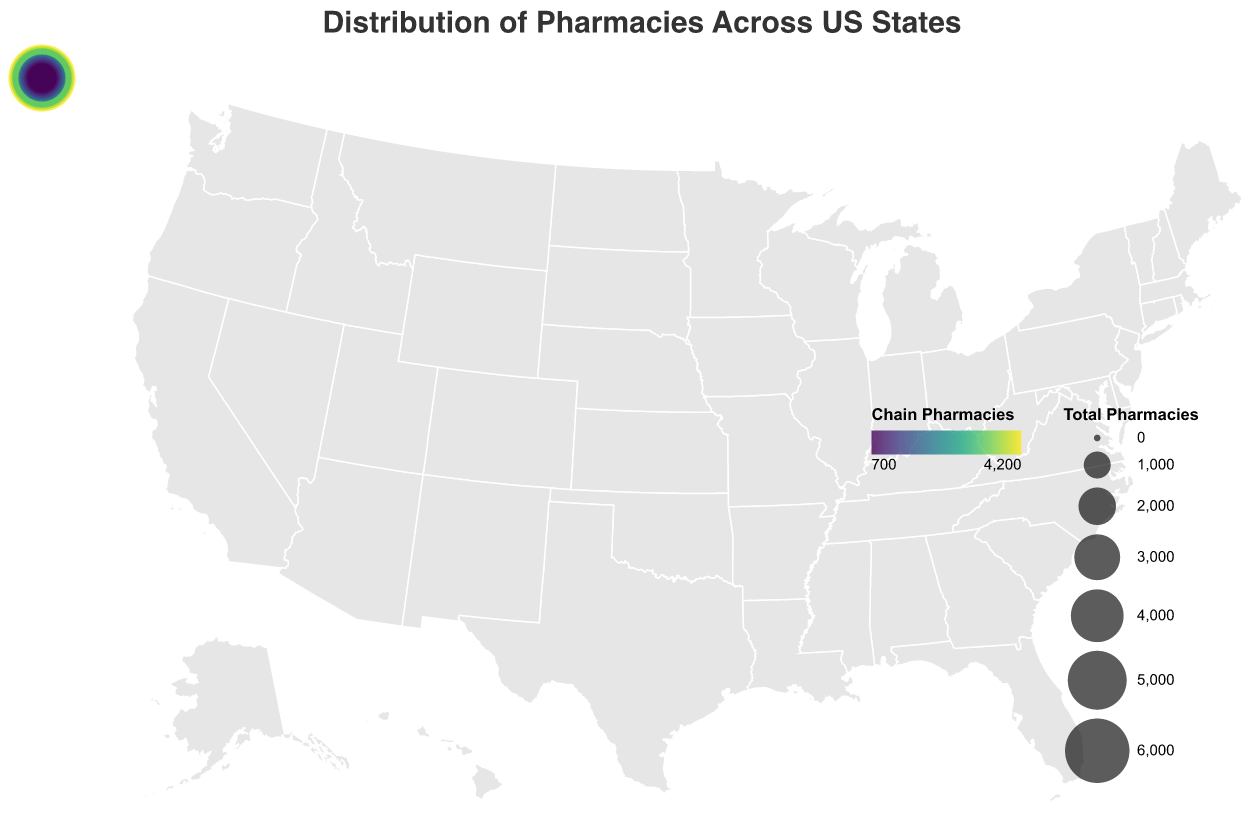What's the total number of pharmacies in Pennsylvania and Ohio combined? Look at the total number of pharmacies in Pennsylvania (3000) and Ohio (2800) and add them together: 3000 + 2800 = 5800.
Answer: 5800 How many more independent pharmacies are in California compared to Florida? Compare the "Independent Pharmacies" values for California (2300) and Florida (1600), then subtract: 2300 - 1600 = 700.
Answer: 700 Among the states listed, which one has the smallest number of chain pharmacies? Look at the "Chain Pharmacies" values in the tooltip for each state and find the smallest value, which belongs to Colorado with 700 chain pharmacies.
Answer: Colorado What is the average number of independent pharmacies in Georgia, North Carolina, and New Jersey? Check the "Independent Pharmacies" count for Georgia (900), North Carolina (900), and New Jersey (800). Add these values and divide by the number of states: (900 + 900 + 800) / 3 = 866.67.
Answer: 866.67 Which state has a larger proportion of independent pharmacies compared to chain pharmacies, Tennessee or Wisconsin? Calculate the proportion of independent to chain pharmacies for both states. For Tennessee: 600 / 1000 = 0.6. For Wisconsin: 500 / 900 = 0.56. Tennessee has a larger proportion.
Answer: Tennessee What is the difference in the total number of pharmacies between Michigan and Washington? Look at the total number of pharmacies for Michigan (2500) and Washington (1900), then subtract: 2500 - 1900 = 600.
Answer: 600 Among the top 5 states with the most total pharmacies, which one has the smallest number of independent pharmacies? Check the "Total Pharmacies" for the top 5 states (California, Texas, New York, Florida, and Illinois) and compare their "Independent Pharmacies" values. Illinois has the smallest number of independent pharmacies with 1100.
Answer: Illinois Which state appears to have a more balanced distribution between chain and independent pharmacies, Arizona or Missouri? Compare the ratio of chain to independent pharmacies for both states. For Arizona: 800 chain to 500 independent (ratio 1.6). For Missouri: 900 chain to 600 independent (ratio 1.5). Missouri is more balanced.
Answer: Missouri 